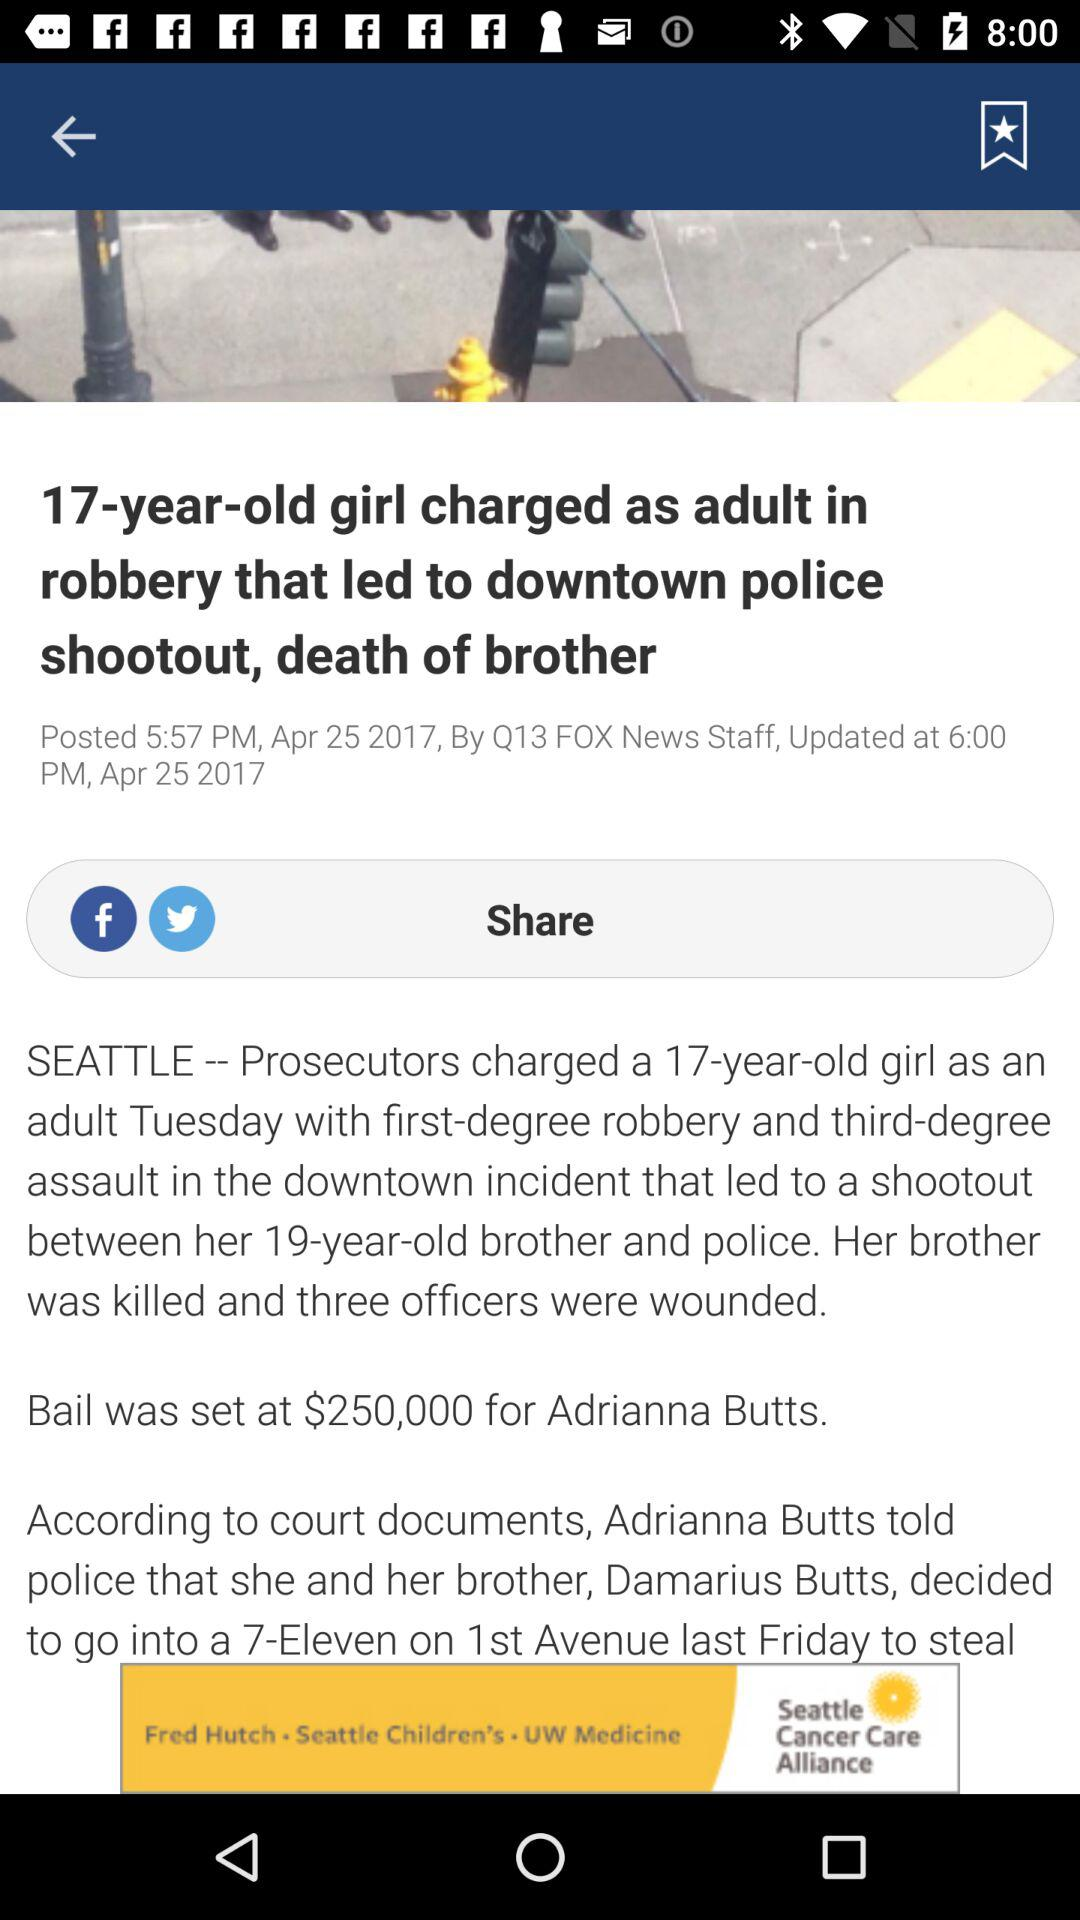When was the news updated? The news was updated on April 25, 2017 at 6:00 p.m. 